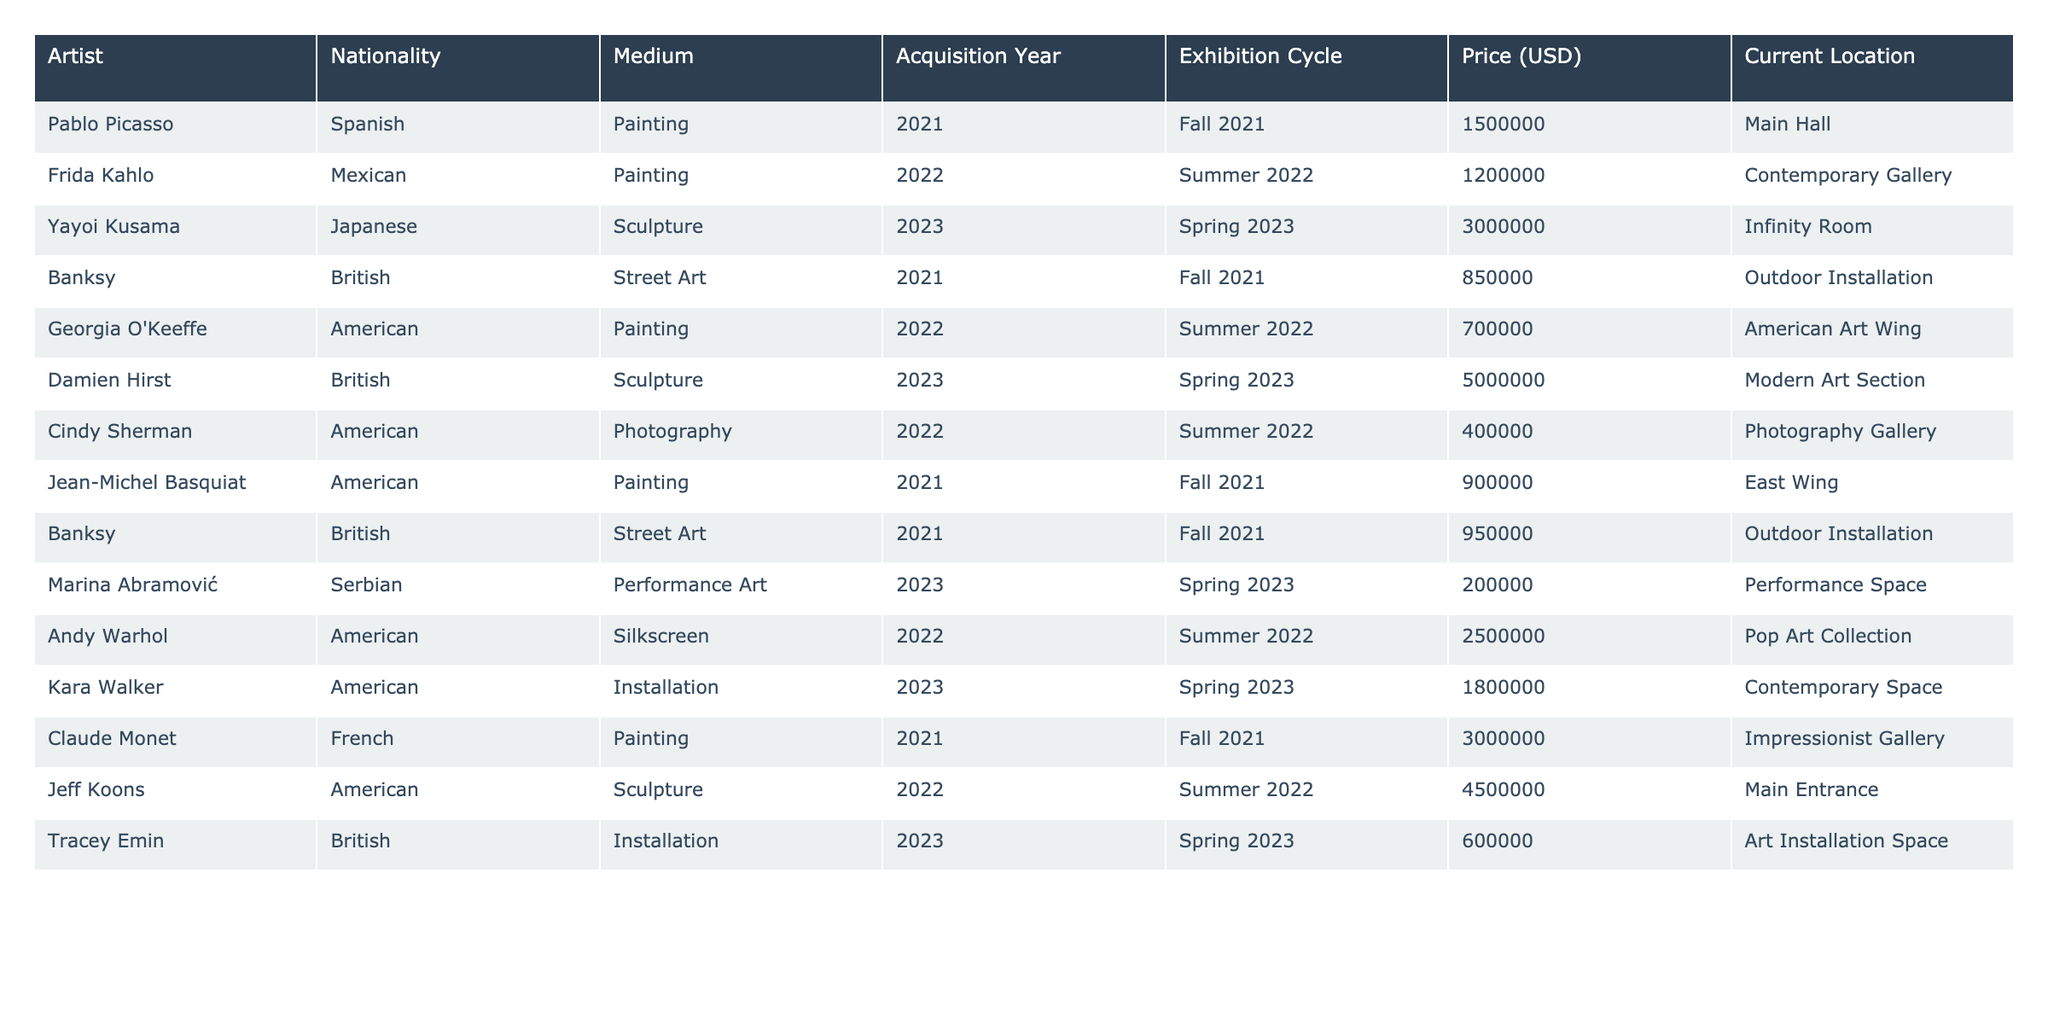What is the highest acquisition price in the table? The highest value in the "Price (USD)" column is 5000000, which corresponds to Damien Hirst's artwork acquired in 2023.
Answer: 5000000 How many artists were acquired during the Summer 2022 exhibition cycle? By checking the "Exhibition Cycle" column, there are three artists listed for Summer 2022: Frida Kahlo, Georgia O'Keeffe, and Cindy Sherman.
Answer: 3 Which artist's piece is located in the Infinity Room? The entry for Yayoi Kusama indicates that her sculpture is located in the Infinity Room, as stated in the "Current Location" column.
Answer: Yayoi Kusama What is the total acquisition cost for all artists acquired in the Fall 2021 exhibition cycle? The acquisition costs for Fall 2021 are: 1500000 (Picasso) + 850000 (Banksy) + 900000 (Basquiat) + 3000000 (Monet) + 950000 (Banksy) = 6900000.
Answer: 6900000 Is there any artist from the table whose works are located in both the Outdoor Installation and the Contemporary Gallery? Banksy has two entries: one for the Outdoor Installation and another for the same medium, but no artist has works in both locations simultaneously.
Answer: No Which nationality has the highest number of artists represented in the table? By counting the nationalities, American artists (O'Keeffe, Sherman, Warhol, Kara Walker) total four entries, the highest compared to others.
Answer: American What is the average price of sculptures acquired in the Spring 2023 exhibition cycle? The prices for sculptures in Spring 2023 are: 3000000 (Yayoi Kusama), 5000000 (Damien Hirst), and 1800000 (Kara Walker), yielding an average of (3000000 + 5000000 + 1800000) / 3 = 3266666.67.
Answer: 3266666.67 Which artist acquired in 2022 had the lowest price? Looking at the prices for 2022 acquisitions, Georgia O'Keeffe at 700000 has the lowest price among the artists listed.
Answer: Georgia O'Keeffe How many different mediums are represented in the acquisitions for Spring 2023? The table shows three different mediums: Sculpture (Yayoi Kusama and Damien Hirst), Performance Art (Marina Abramović), and Installation (Tracey Emin), totaling three unique mediums.
Answer: 3 Was there any artwork acquired in 2022 that is priced above 2000000? Checking the prices for 2022 reveals that Warhol's silkscreen at 2500000 qualifies, indicating there was at least one acquisition priced above that amount.
Answer: Yes 